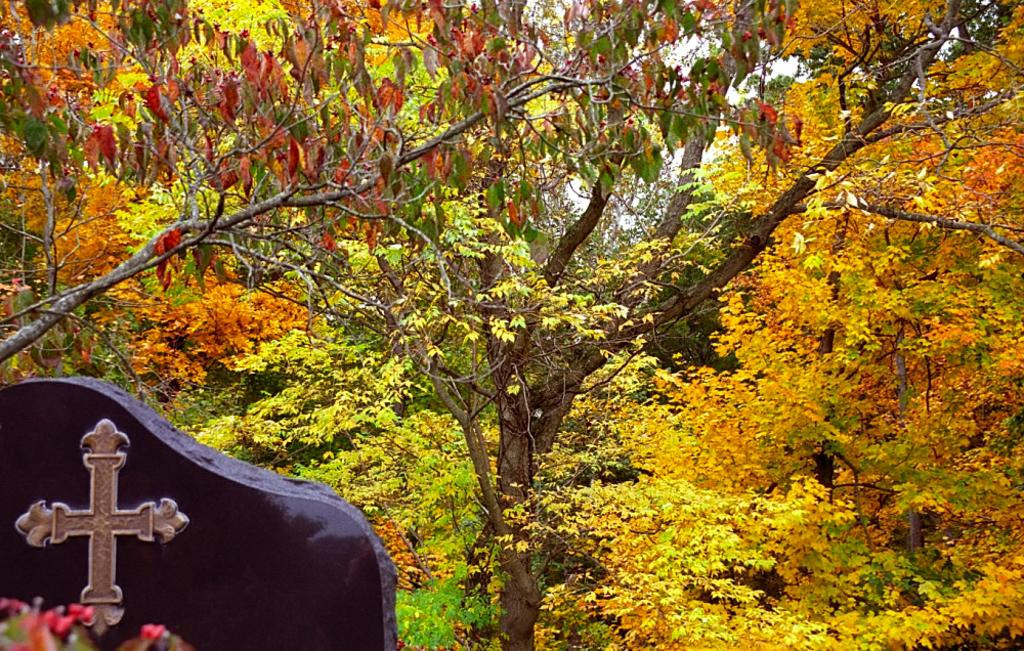What type of natural elements can be seen in the image? There are trees in the image. What religious symbol is present in the image? There is a Christian symbol on a black cloth in the image. On which side of the image is the Christian symbol located? The Christian symbol is on the left side of the image. What type of suit is the man wearing in the image? There is no man present in the image, so it is not possible to determine what type of suit he might be wearing. 